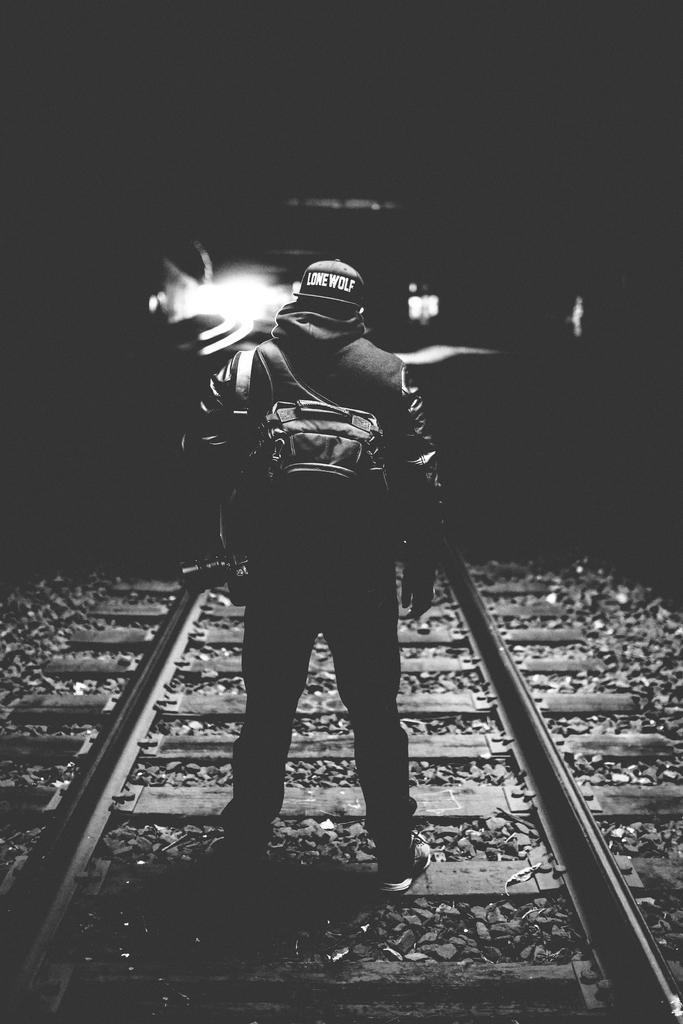Could you give a brief overview of what you see in this image? In this image I can see the person wearing the dress, bag and helmet. I can see the person standing on the track. And there is a black background. 